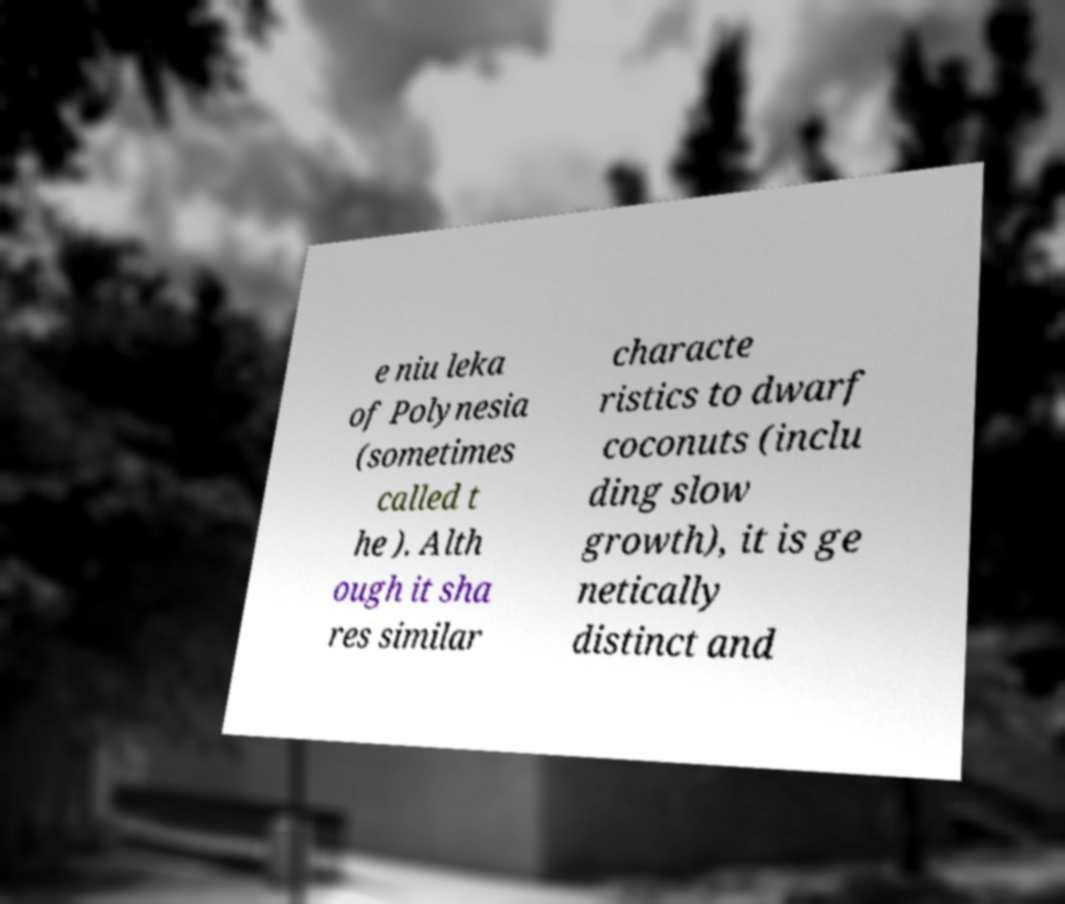There's text embedded in this image that I need extracted. Can you transcribe it verbatim? e niu leka of Polynesia (sometimes called t he ). Alth ough it sha res similar characte ristics to dwarf coconuts (inclu ding slow growth), it is ge netically distinct and 